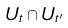<formula> <loc_0><loc_0><loc_500><loc_500>U _ { t } \cap U _ { t ^ { \prime } }</formula> 